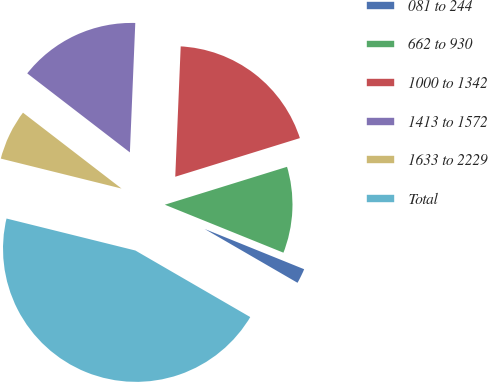Convert chart. <chart><loc_0><loc_0><loc_500><loc_500><pie_chart><fcel>081 to 244<fcel>662 to 930<fcel>1000 to 1342<fcel>1413 to 1572<fcel>1633 to 2229<fcel>Total<nl><fcel>2.24%<fcel>10.9%<fcel>19.55%<fcel>15.22%<fcel>6.57%<fcel>45.51%<nl></chart> 